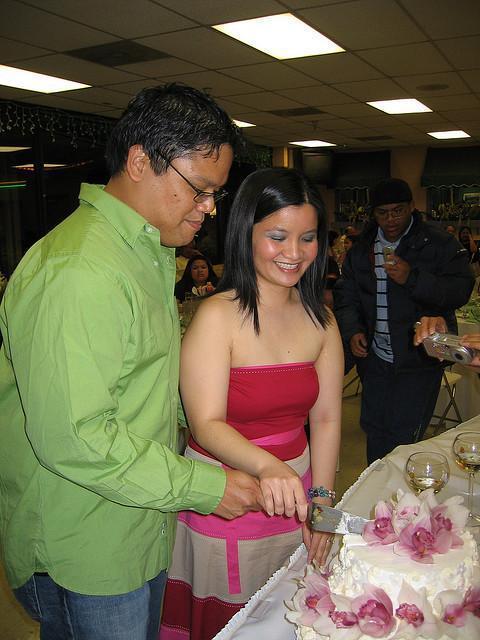How many cakes are in the picture?
Give a very brief answer. 1. How many people are there?
Give a very brief answer. 3. 